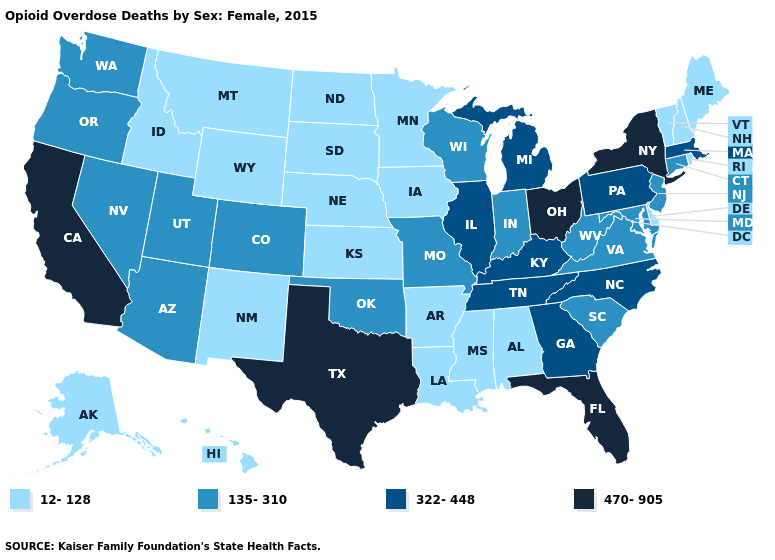Does New Hampshire have a higher value than Ohio?
Concise answer only. No. Name the states that have a value in the range 135-310?
Answer briefly. Arizona, Colorado, Connecticut, Indiana, Maryland, Missouri, Nevada, New Jersey, Oklahoma, Oregon, South Carolina, Utah, Virginia, Washington, West Virginia, Wisconsin. Is the legend a continuous bar?
Write a very short answer. No. Does Iowa have a lower value than Arizona?
Give a very brief answer. Yes. What is the highest value in the USA?
Write a very short answer. 470-905. Name the states that have a value in the range 12-128?
Quick response, please. Alabama, Alaska, Arkansas, Delaware, Hawaii, Idaho, Iowa, Kansas, Louisiana, Maine, Minnesota, Mississippi, Montana, Nebraska, New Hampshire, New Mexico, North Dakota, Rhode Island, South Dakota, Vermont, Wyoming. Name the states that have a value in the range 12-128?
Be succinct. Alabama, Alaska, Arkansas, Delaware, Hawaii, Idaho, Iowa, Kansas, Louisiana, Maine, Minnesota, Mississippi, Montana, Nebraska, New Hampshire, New Mexico, North Dakota, Rhode Island, South Dakota, Vermont, Wyoming. Does Alabama have a lower value than Maryland?
Be succinct. Yes. Name the states that have a value in the range 322-448?
Keep it brief. Georgia, Illinois, Kentucky, Massachusetts, Michigan, North Carolina, Pennsylvania, Tennessee. Does Michigan have the lowest value in the USA?
Short answer required. No. What is the value of Utah?
Concise answer only. 135-310. What is the value of Tennessee?
Concise answer only. 322-448. Which states have the lowest value in the USA?
Keep it brief. Alabama, Alaska, Arkansas, Delaware, Hawaii, Idaho, Iowa, Kansas, Louisiana, Maine, Minnesota, Mississippi, Montana, Nebraska, New Hampshire, New Mexico, North Dakota, Rhode Island, South Dakota, Vermont, Wyoming. What is the value of New Jersey?
Concise answer only. 135-310. Does the map have missing data?
Be succinct. No. 